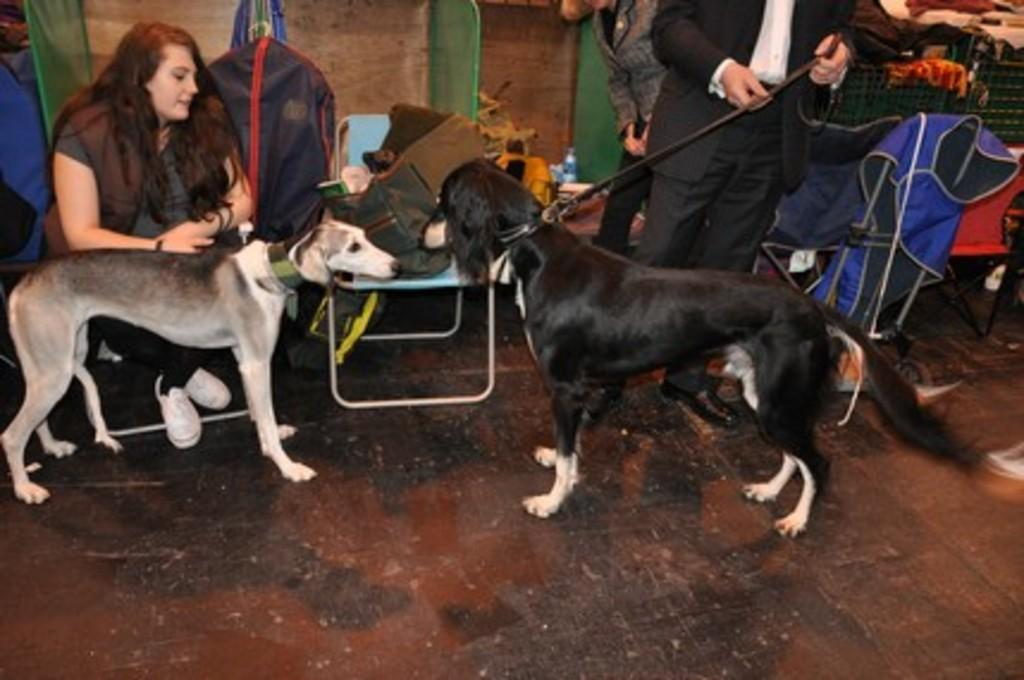Who or what is present in the image? There are people and two dogs in the image. Can you describe the position of the chair in the image? There is a chair in the middle of the image. What type of cream is being used to talk to the dogs in the image? There is no cream or talking to the dogs in the image. 